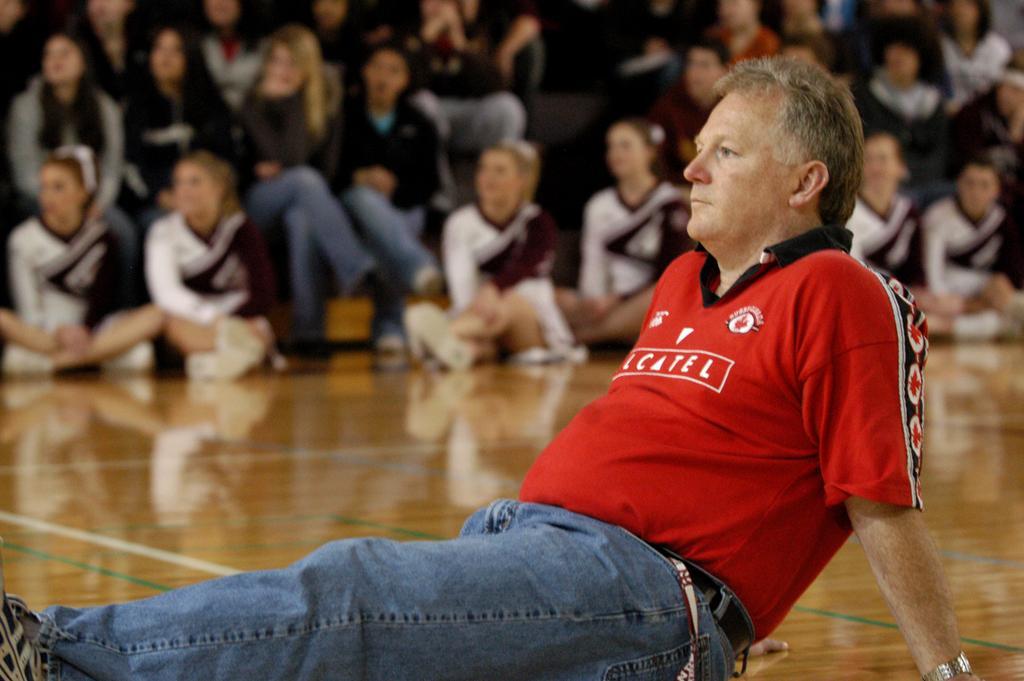How would you summarize this image in a sentence or two? In this picture we can see people sitting on the floor. In the background we can see people sitting. 